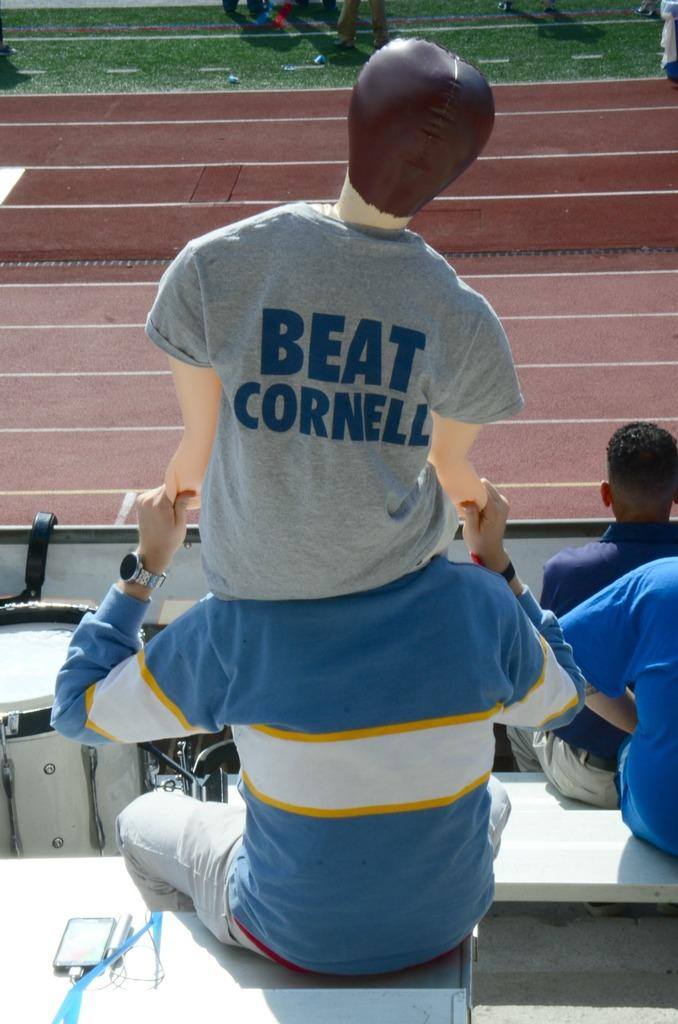<image>
Render a clear and concise summary of the photo. People are spectating a track meet and one of their shirts says Beat Cornell. 